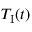Convert formula to latex. <formula><loc_0><loc_0><loc_500><loc_500>T _ { I } ( t )</formula> 